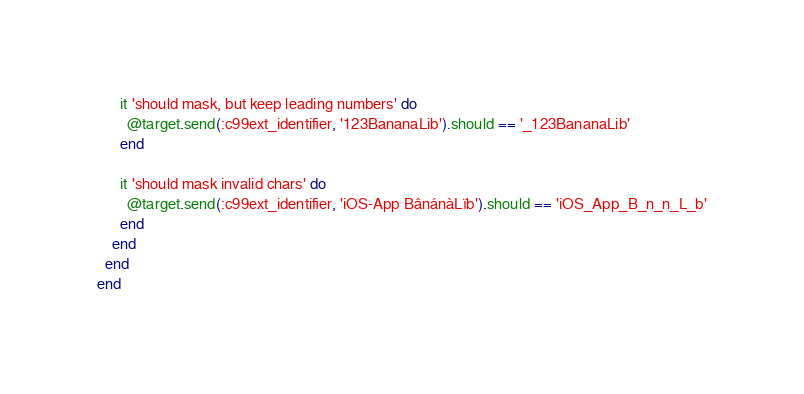<code> <loc_0><loc_0><loc_500><loc_500><_Ruby_>
      it 'should mask, but keep leading numbers' do
        @target.send(:c99ext_identifier, '123BananaLib').should == '_123BananaLib'
      end

      it 'should mask invalid chars' do
        @target.send(:c99ext_identifier, 'iOS-App BânánàLïb').should == 'iOS_App_B_n_n_L_b'
      end
    end
  end
end
</code> 